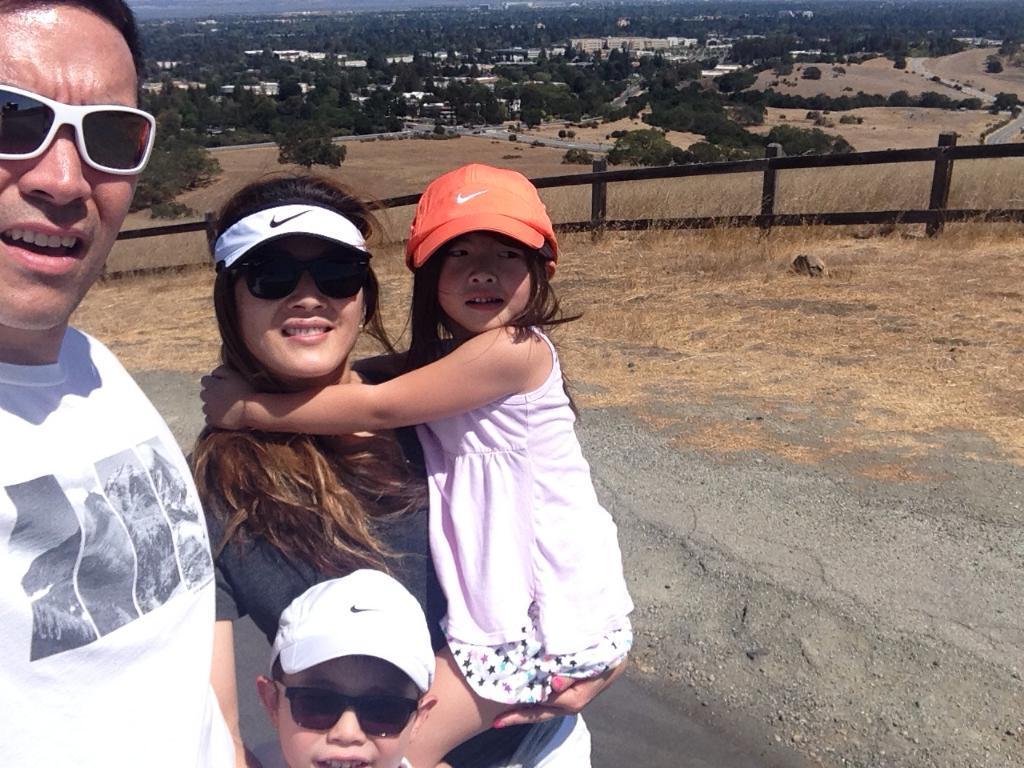Could you give a brief overview of what you see in this image? In this image there is a couple with their children's are standing on the path, behind them there is a wooden fence. In the background there are trees and buildings. 